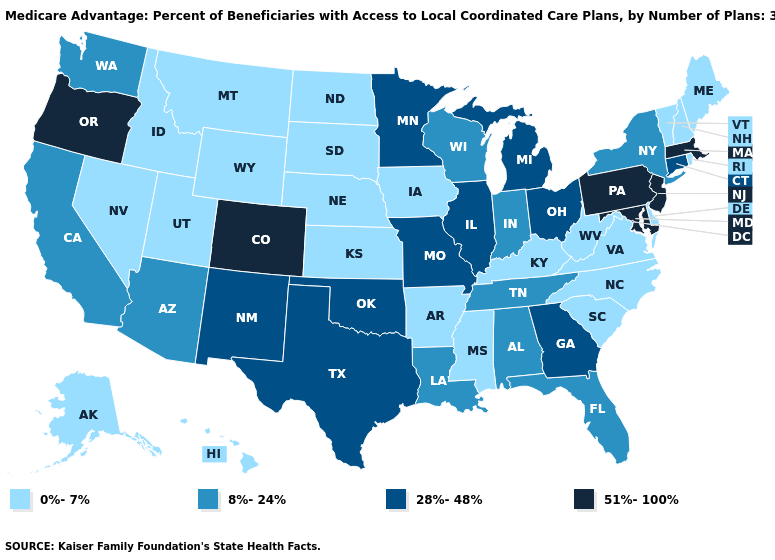Does the first symbol in the legend represent the smallest category?
Be succinct. Yes. Does New Jersey have a higher value than Maryland?
Keep it brief. No. What is the value of Colorado?
Quick response, please. 51%-100%. Does New Mexico have the lowest value in the West?
Give a very brief answer. No. Name the states that have a value in the range 8%-24%?
Write a very short answer. Alabama, Arizona, California, Florida, Indiana, Louisiana, New York, Tennessee, Washington, Wisconsin. Which states have the lowest value in the USA?
Short answer required. Alaska, Arkansas, Delaware, Hawaii, Iowa, Idaho, Kansas, Kentucky, Maine, Mississippi, Montana, North Carolina, North Dakota, Nebraska, New Hampshire, Nevada, Rhode Island, South Carolina, South Dakota, Utah, Virginia, Vermont, West Virginia, Wyoming. Does Colorado have the highest value in the West?
Short answer required. Yes. What is the lowest value in the USA?
Write a very short answer. 0%-7%. Does the map have missing data?
Write a very short answer. No. Does California have the highest value in the USA?
Write a very short answer. No. Name the states that have a value in the range 28%-48%?
Be succinct. Connecticut, Georgia, Illinois, Michigan, Minnesota, Missouri, New Mexico, Ohio, Oklahoma, Texas. Which states have the lowest value in the USA?
Be succinct. Alaska, Arkansas, Delaware, Hawaii, Iowa, Idaho, Kansas, Kentucky, Maine, Mississippi, Montana, North Carolina, North Dakota, Nebraska, New Hampshire, Nevada, Rhode Island, South Carolina, South Dakota, Utah, Virginia, Vermont, West Virginia, Wyoming. Name the states that have a value in the range 28%-48%?
Short answer required. Connecticut, Georgia, Illinois, Michigan, Minnesota, Missouri, New Mexico, Ohio, Oklahoma, Texas. What is the highest value in the USA?
Answer briefly. 51%-100%. 